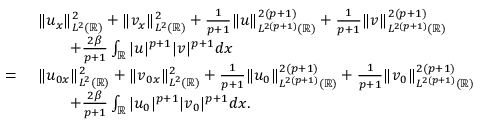Convert formula to latex. <formula><loc_0><loc_0><loc_500><loc_500>\begin{array} { r l } & { \| u _ { x } \| _ { L ^ { 2 } ( \mathbb { R } ) } ^ { 2 } + \| v _ { x } \| _ { L ^ { 2 } ( \mathbb { R } ) } ^ { 2 } + \frac { 1 } { p + 1 } \| u \| _ { L ^ { 2 ( p + 1 ) } ( \mathbb { R } ) } ^ { 2 ( p + 1 ) } + \frac { 1 } { p + 1 } \| v \| _ { L ^ { 2 ( p + 1 ) } ( \mathbb { R } ) } ^ { 2 ( p + 1 ) } } \\ & { \quad + \frac { 2 \beta } { p + 1 } \int _ { \mathbb { R } } | u | ^ { p + 1 } | v | ^ { p + 1 } d x } \\ { = \ } & { \| u _ { 0 x } \| _ { L ^ { 2 } ( \mathbb { R } ) } ^ { 2 } + \| v _ { 0 x } \| _ { L ^ { 2 } ( \mathbb { R } ) } ^ { 2 } + \frac { 1 } { p + 1 } \| u _ { 0 } \| _ { L ^ { 2 ( p + 1 ) } ( \mathbb { R } ) } ^ { 2 ( p + 1 ) } + \frac { 1 } { p + 1 } \| v _ { 0 } \| _ { L ^ { 2 ( p + 1 ) } ( \mathbb { R } ) } ^ { 2 ( p + 1 ) } } \\ & { \quad + \frac { 2 \beta } { p + 1 } \int _ { \mathbb { R } } | u _ { 0 } | ^ { p + 1 } | v _ { 0 } | ^ { p + 1 } d x . } \end{array}</formula> 